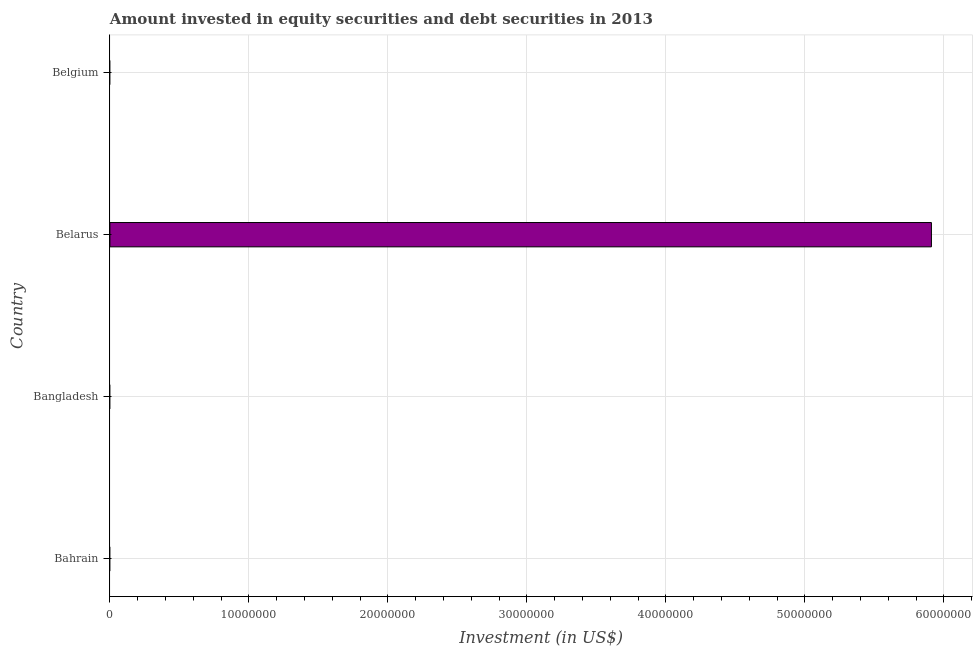Does the graph contain any zero values?
Make the answer very short. Yes. What is the title of the graph?
Your answer should be compact. Amount invested in equity securities and debt securities in 2013. What is the label or title of the X-axis?
Make the answer very short. Investment (in US$). What is the label or title of the Y-axis?
Your response must be concise. Country. What is the portfolio investment in Belgium?
Provide a succinct answer. 0. Across all countries, what is the maximum portfolio investment?
Provide a short and direct response. 5.91e+07. In which country was the portfolio investment maximum?
Keep it short and to the point. Belarus. What is the sum of the portfolio investment?
Provide a short and direct response. 5.91e+07. What is the average portfolio investment per country?
Provide a succinct answer. 1.48e+07. What is the median portfolio investment?
Your response must be concise. 0. What is the difference between the highest and the lowest portfolio investment?
Provide a short and direct response. 5.91e+07. In how many countries, is the portfolio investment greater than the average portfolio investment taken over all countries?
Offer a terse response. 1. How many bars are there?
Your answer should be compact. 1. Are all the bars in the graph horizontal?
Make the answer very short. Yes. How many countries are there in the graph?
Ensure brevity in your answer.  4. What is the Investment (in US$) in Bahrain?
Offer a terse response. 0. What is the Investment (in US$) of Bangladesh?
Offer a terse response. 0. What is the Investment (in US$) of Belarus?
Your response must be concise. 5.91e+07. What is the Investment (in US$) of Belgium?
Your answer should be compact. 0. 